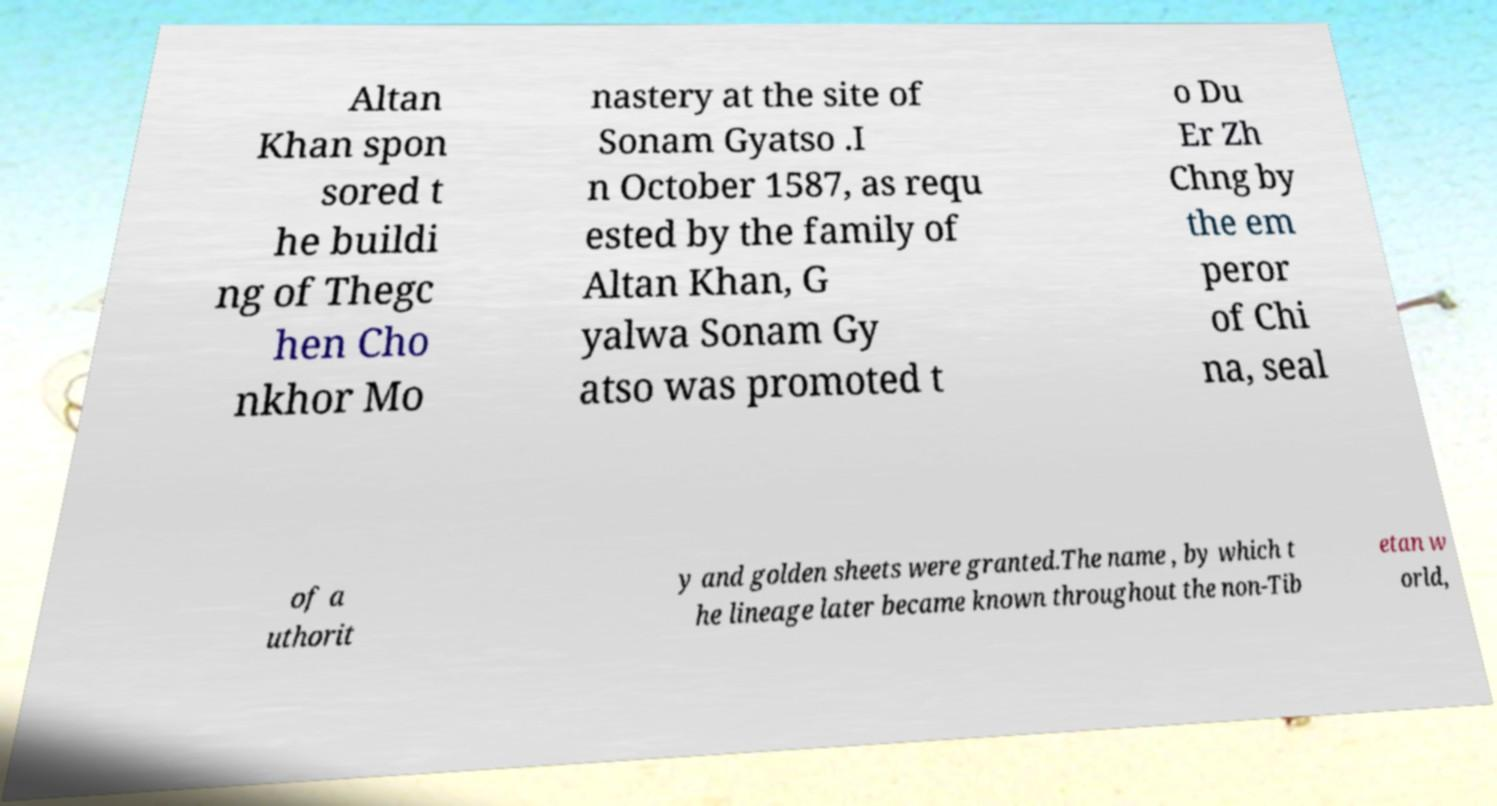Could you assist in decoding the text presented in this image and type it out clearly? Altan Khan spon sored t he buildi ng of Thegc hen Cho nkhor Mo nastery at the site of Sonam Gyatso .I n October 1587, as requ ested by the family of Altan Khan, G yalwa Sonam Gy atso was promoted t o Du Er Zh Chng by the em peror of Chi na, seal of a uthorit y and golden sheets were granted.The name , by which t he lineage later became known throughout the non-Tib etan w orld, 